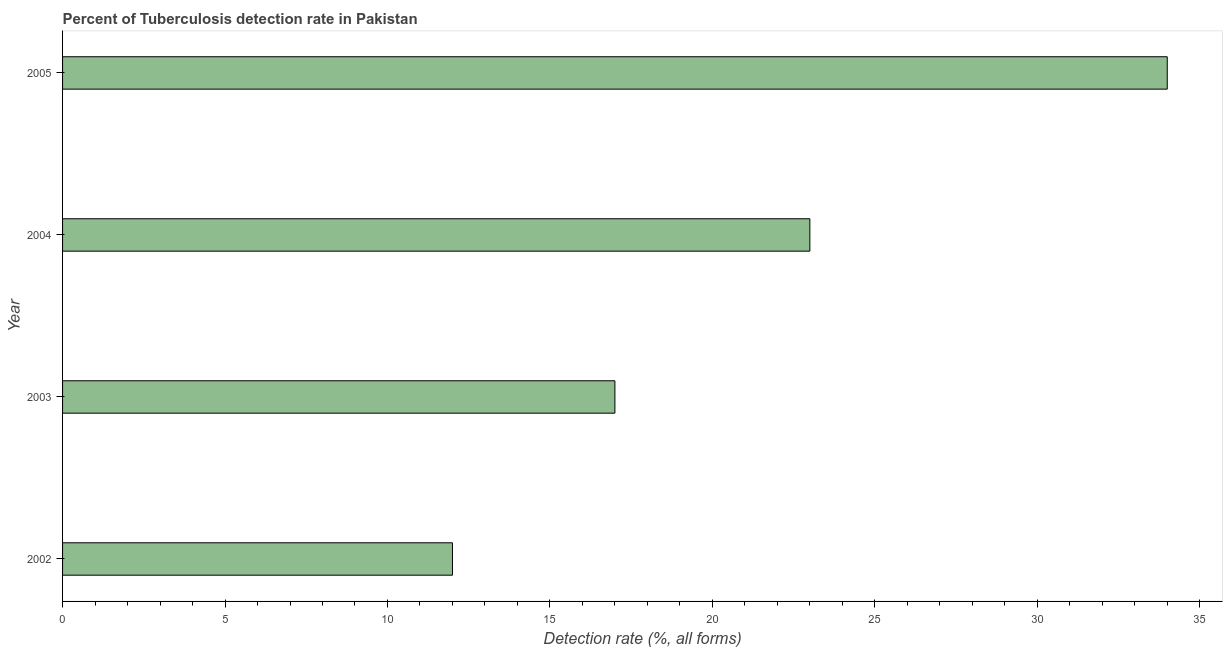What is the title of the graph?
Give a very brief answer. Percent of Tuberculosis detection rate in Pakistan. What is the label or title of the X-axis?
Ensure brevity in your answer.  Detection rate (%, all forms). What is the detection rate of tuberculosis in 2005?
Make the answer very short. 34. Across all years, what is the maximum detection rate of tuberculosis?
Make the answer very short. 34. Across all years, what is the minimum detection rate of tuberculosis?
Your answer should be compact. 12. In which year was the detection rate of tuberculosis maximum?
Give a very brief answer. 2005. In which year was the detection rate of tuberculosis minimum?
Make the answer very short. 2002. What is the sum of the detection rate of tuberculosis?
Offer a terse response. 86. What is the difference between the detection rate of tuberculosis in 2003 and 2004?
Give a very brief answer. -6. What is the average detection rate of tuberculosis per year?
Offer a very short reply. 21.5. What is the median detection rate of tuberculosis?
Keep it short and to the point. 20. In how many years, is the detection rate of tuberculosis greater than 13 %?
Provide a succinct answer. 3. What is the ratio of the detection rate of tuberculosis in 2002 to that in 2003?
Give a very brief answer. 0.71. Is the detection rate of tuberculosis in 2003 less than that in 2005?
Offer a terse response. Yes. Is the difference between the detection rate of tuberculosis in 2003 and 2005 greater than the difference between any two years?
Provide a short and direct response. No. What is the difference between the highest and the second highest detection rate of tuberculosis?
Your answer should be very brief. 11. Is the sum of the detection rate of tuberculosis in 2002 and 2004 greater than the maximum detection rate of tuberculosis across all years?
Ensure brevity in your answer.  Yes. What is the difference between the highest and the lowest detection rate of tuberculosis?
Make the answer very short. 22. Are all the bars in the graph horizontal?
Your answer should be compact. Yes. How many years are there in the graph?
Provide a succinct answer. 4. What is the difference between two consecutive major ticks on the X-axis?
Ensure brevity in your answer.  5. What is the Detection rate (%, all forms) in 2005?
Your answer should be compact. 34. What is the difference between the Detection rate (%, all forms) in 2002 and 2004?
Your response must be concise. -11. What is the difference between the Detection rate (%, all forms) in 2002 and 2005?
Make the answer very short. -22. What is the difference between the Detection rate (%, all forms) in 2003 and 2005?
Make the answer very short. -17. What is the difference between the Detection rate (%, all forms) in 2004 and 2005?
Provide a short and direct response. -11. What is the ratio of the Detection rate (%, all forms) in 2002 to that in 2003?
Ensure brevity in your answer.  0.71. What is the ratio of the Detection rate (%, all forms) in 2002 to that in 2004?
Make the answer very short. 0.52. What is the ratio of the Detection rate (%, all forms) in 2002 to that in 2005?
Offer a very short reply. 0.35. What is the ratio of the Detection rate (%, all forms) in 2003 to that in 2004?
Make the answer very short. 0.74. What is the ratio of the Detection rate (%, all forms) in 2004 to that in 2005?
Your response must be concise. 0.68. 